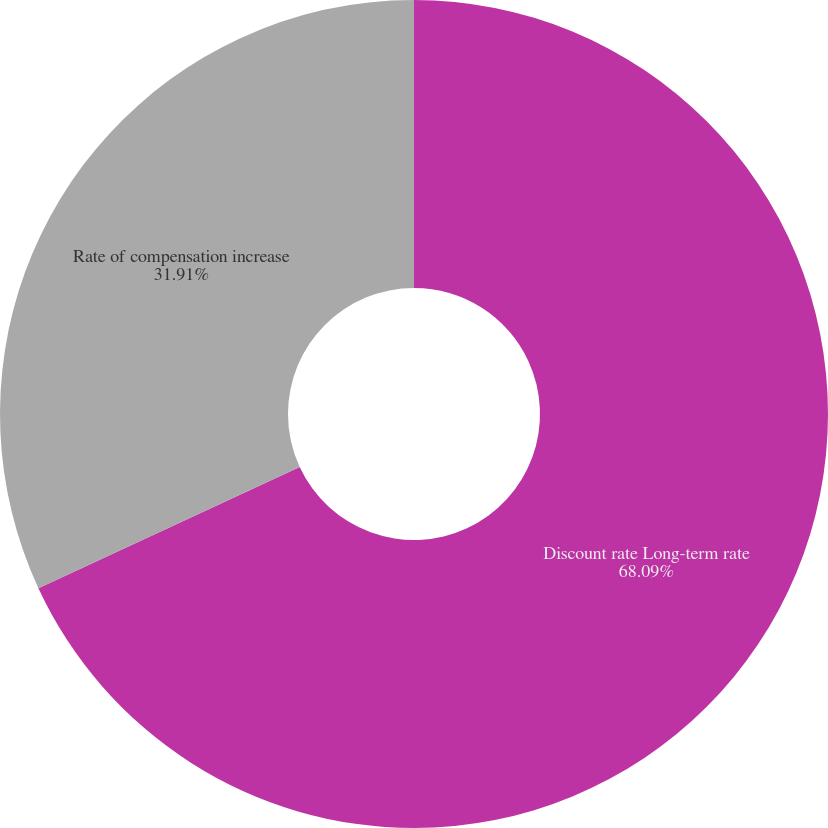<chart> <loc_0><loc_0><loc_500><loc_500><pie_chart><fcel>Discount rate Long-term rate<fcel>Rate of compensation increase<nl><fcel>68.09%<fcel>31.91%<nl></chart> 